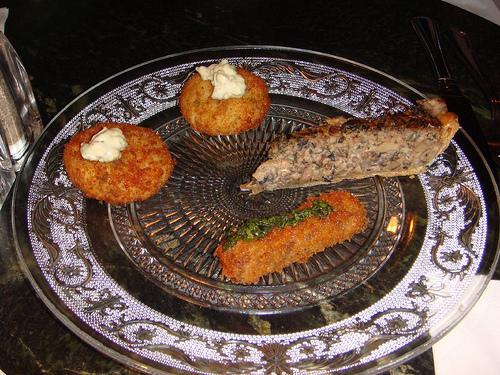How much food is on this plate?
Write a very short answer. 4. Is the plate see through?
Give a very brief answer. Yes. Was it a two-layer cake?
Short answer required. No. Is there are sweet item on the plate?
Answer briefly. No. 